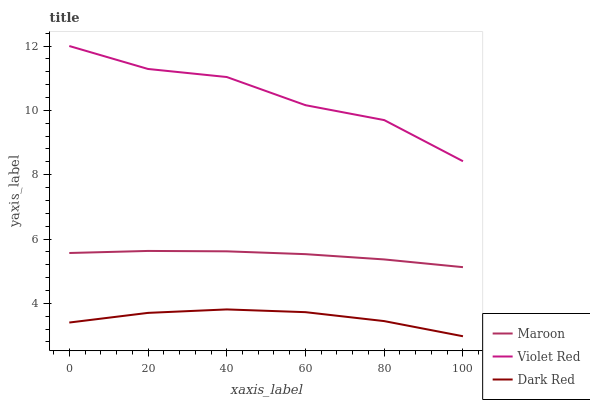Does Maroon have the minimum area under the curve?
Answer yes or no. No. Does Maroon have the maximum area under the curve?
Answer yes or no. No. Is Violet Red the smoothest?
Answer yes or no. No. Is Maroon the roughest?
Answer yes or no. No. Does Maroon have the lowest value?
Answer yes or no. No. Does Maroon have the highest value?
Answer yes or no. No. Is Dark Red less than Violet Red?
Answer yes or no. Yes. Is Violet Red greater than Maroon?
Answer yes or no. Yes. Does Dark Red intersect Violet Red?
Answer yes or no. No. 